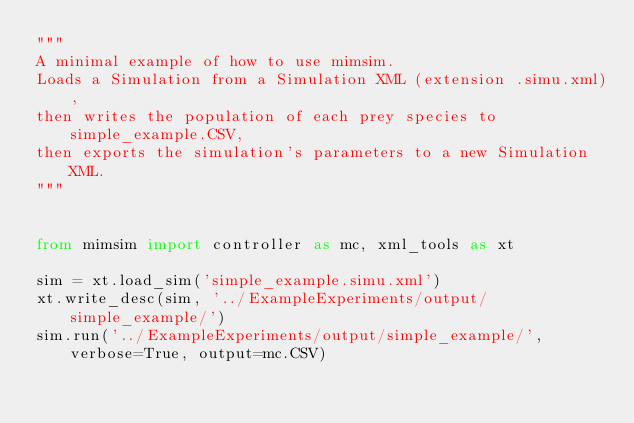<code> <loc_0><loc_0><loc_500><loc_500><_Python_>"""
A minimal example of how to use mimsim.
Loads a Simulation from a Simulation XML (extension .simu.xml),
then writes the population of each prey species to simple_example.CSV,
then exports the simulation's parameters to a new Simulation XML.
"""


from mimsim import controller as mc, xml_tools as xt

sim = xt.load_sim('simple_example.simu.xml')
xt.write_desc(sim, '../ExampleExperiments/output/simple_example/')
sim.run('../ExampleExperiments/output/simple_example/', verbose=True, output=mc.CSV)
</code> 